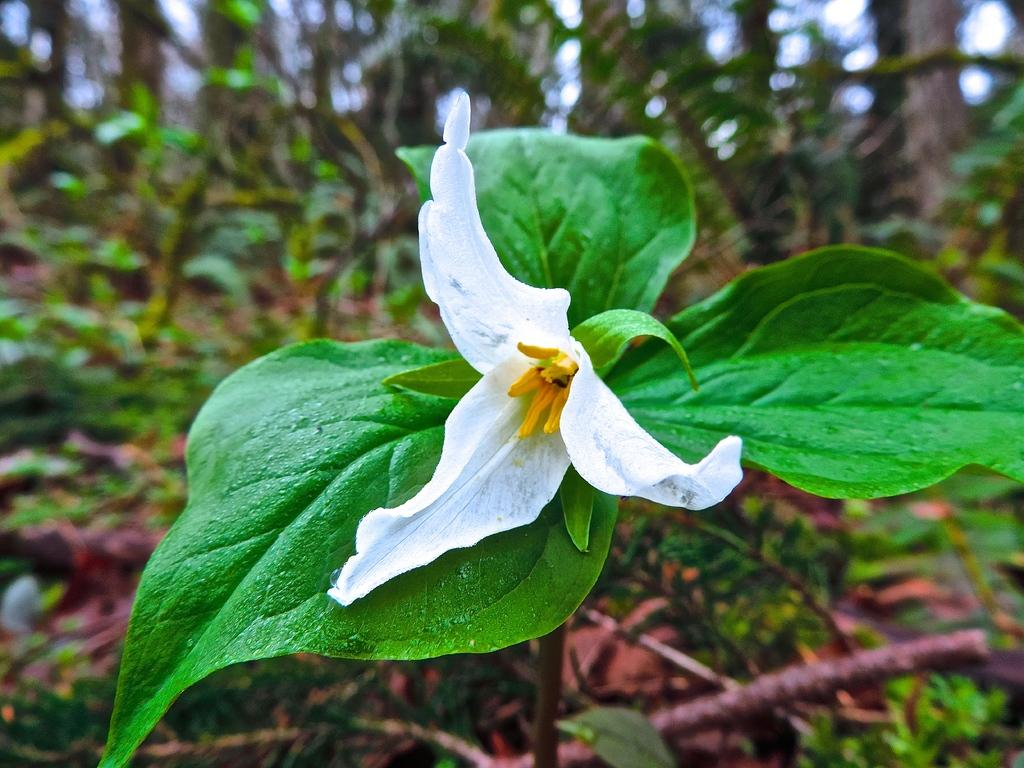What type of flower is in the image? There is a white color flower in the image. What can be seen in the front of the image? A: There are leaves in the front of the image. What is visible in the background of the image? There are plants in the background of the image. What type of ink is used to write the name of the flower on the skin in the image? There is no ink or writing on the skin in the image, as it features a white color flower with leaves and plants in the background. 